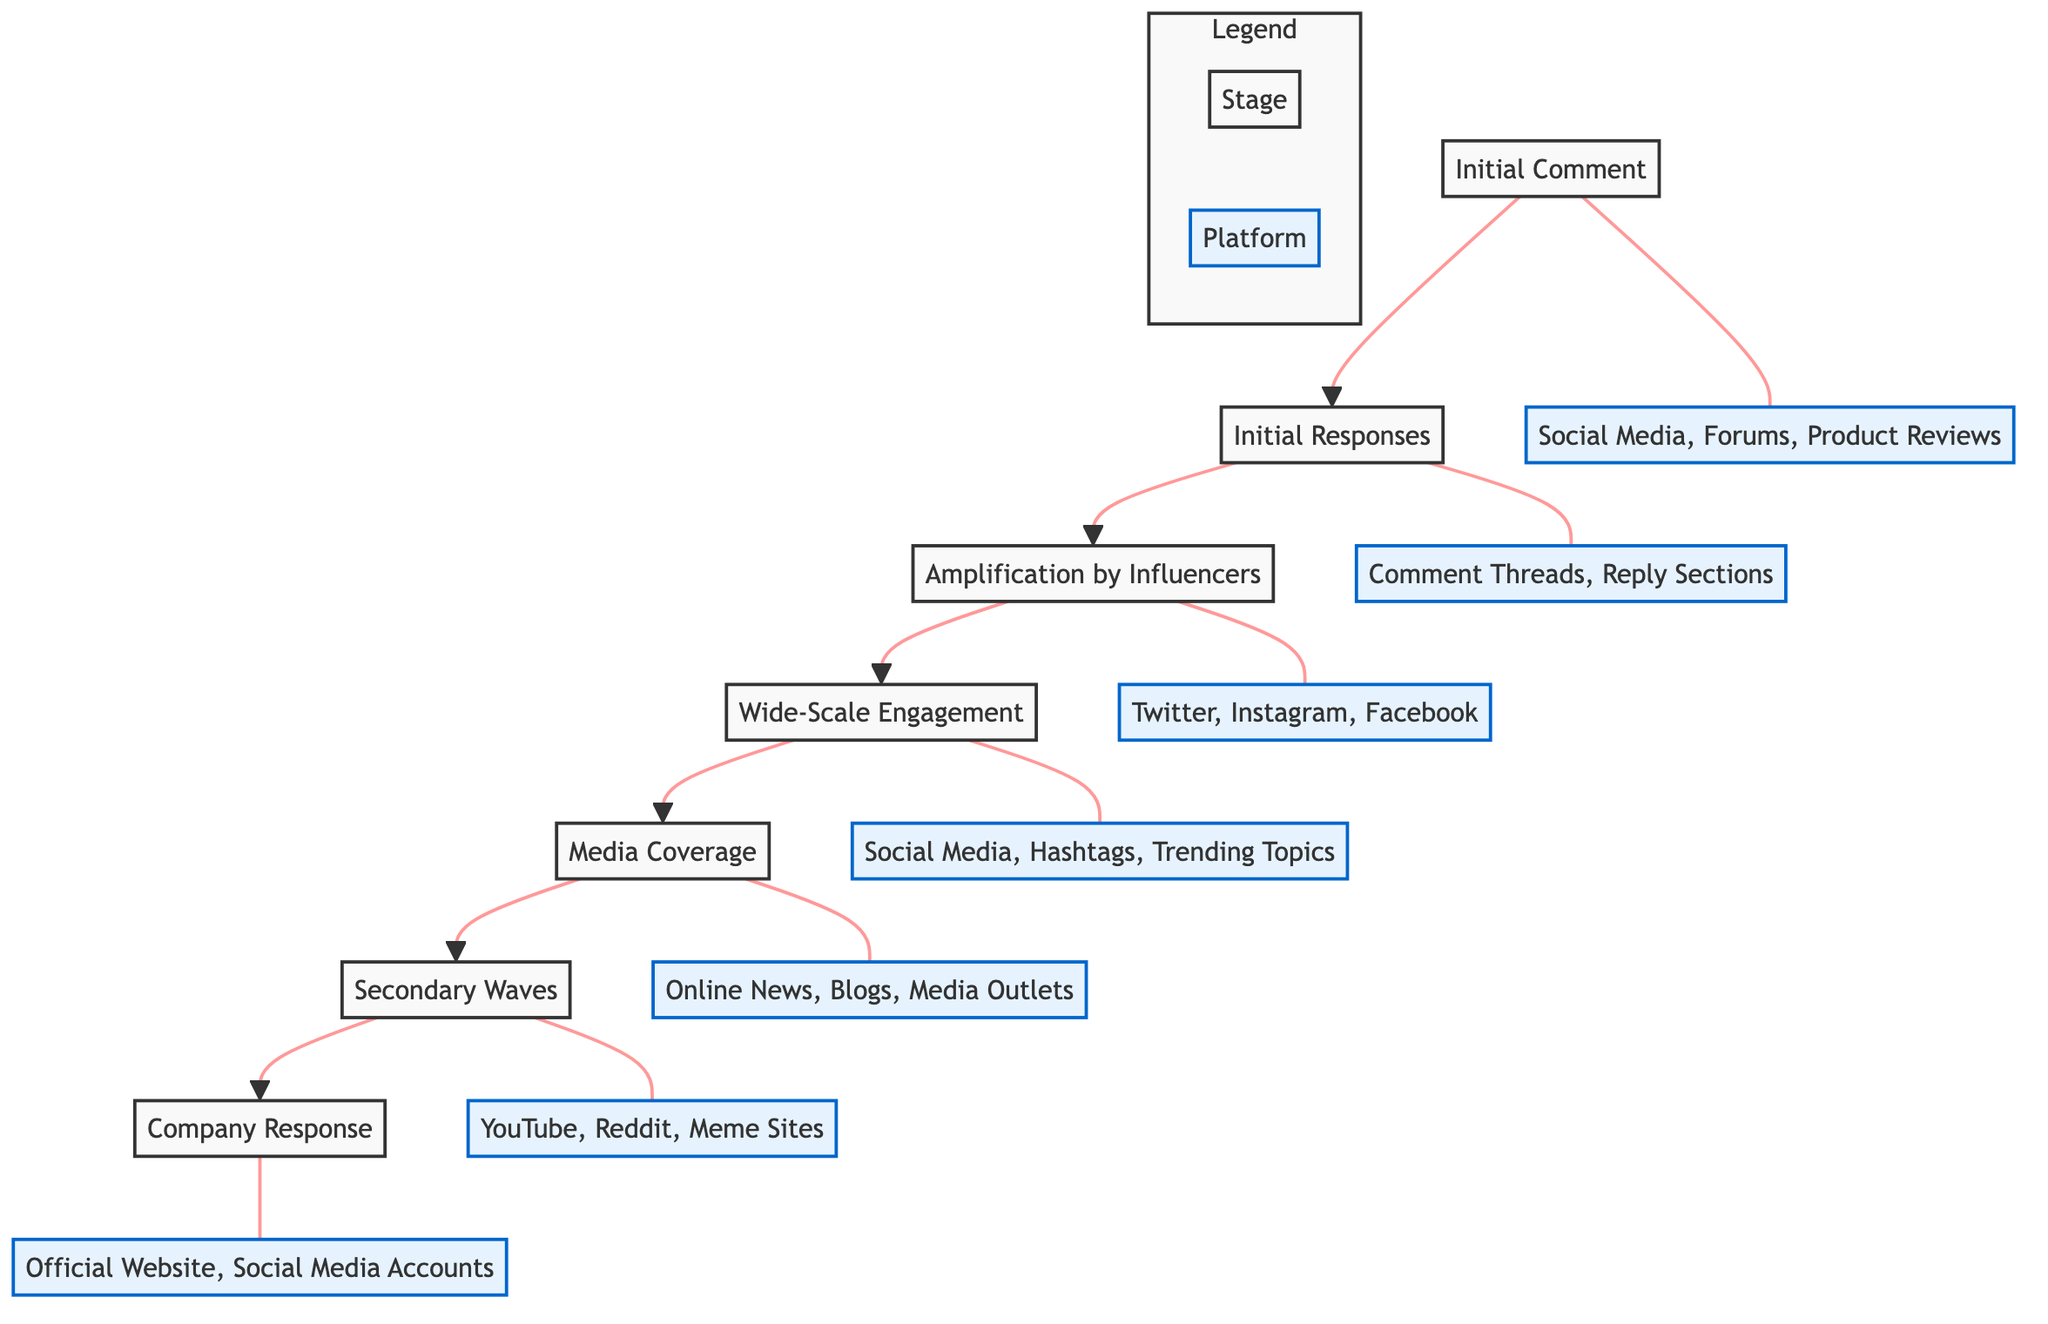What is the initial stage of the evolution? The diagram starts with the "Initial Comment" stage, which is the first step in the flow.
Answer: Initial Comment How many stages are in the diagram? By counting the nodes listed in the flowchart, there are a total of seven distinct stages represented.
Answer: 7 What stage follows "Wide-Scale Engagement"? The flowchart indicates that "Media Coverage" directly follows "Wide-Scale Engagement."
Answer: Media Coverage Which platform is associated with "Amplification by Influencers"? The diagram specifies that "Twitter, Instagram, Facebook" are the platforms linked to the "Amplification by Influencers" stage.
Answer: Twitter, Instagram, Facebook What is the purpose of "Company Response" in the flow? The purpose of the "Company Response" is to address the growing negative sentiment that follows the earlier stages of the negative comment evolution.
Answer: Addressing negative sentiment What stage has the description "A small group of users responds to the negative comment"? The description matches the "Initial Responses" stage in the flowchart, which describes early reactions.
Answer: Initial Responses Which stage introduces a broader audience via news articles? According to the diagram, "Media Coverage" is the stage where news outlets or blogs cover the story, reaching a wider audience.
Answer: Media Coverage What is the relationship between "Initial Responses" and "Amplification by Influencers"? "Initial Responses" leads to "Amplification by Influencers," where responses by users may catch the attention of influential accounts.
Answer: Leads to What occurs during the "Secondary Waves" stage? The "Secondary Waves" stage summarizes the creation of new posts and comments that reference the original negative comment, thereby expanding discussions.
Answer: Creating new posts and comments 